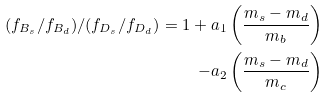<formula> <loc_0><loc_0><loc_500><loc_500>( f _ { B _ { s } } / f _ { B _ { d } } ) / ( f _ { D _ { s } } / f _ { D _ { d } } ) = 1 + a _ { 1 } \left ( \frac { m _ { s } - m _ { d } } { m _ { b } } \right ) \\ - a _ { 2 } \left ( \frac { m _ { s } - m _ { d } } { m _ { c } } \right )</formula> 